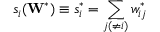Convert formula to latex. <formula><loc_0><loc_0><loc_500><loc_500>s _ { i } ( W ^ { * } ) \equiv s _ { i } ^ { * } = \sum _ { j ( \neq i ) } w _ { i j } ^ { * }</formula> 